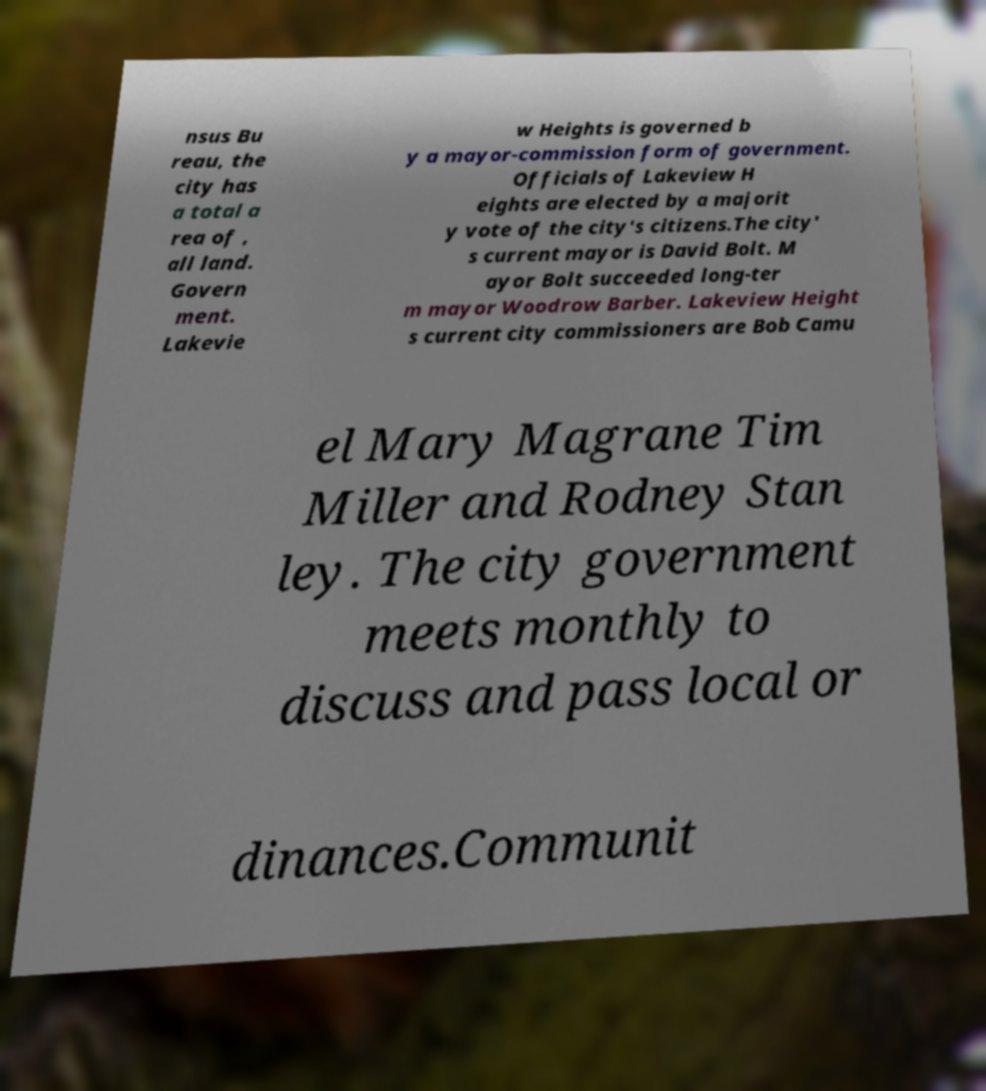Could you assist in decoding the text presented in this image and type it out clearly? nsus Bu reau, the city has a total a rea of , all land. Govern ment. Lakevie w Heights is governed b y a mayor-commission form of government. Officials of Lakeview H eights are elected by a majorit y vote of the city's citizens.The city' s current mayor is David Bolt. M ayor Bolt succeeded long-ter m mayor Woodrow Barber. Lakeview Height s current city commissioners are Bob Camu el Mary Magrane Tim Miller and Rodney Stan ley. The city government meets monthly to discuss and pass local or dinances.Communit 